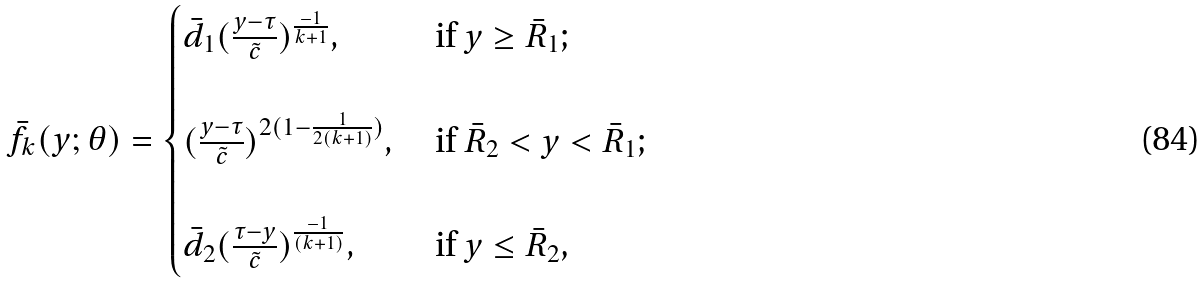Convert formula to latex. <formula><loc_0><loc_0><loc_500><loc_500>\bar { f } _ { k } ( y ; \theta ) = \begin{cases} \bar { d } _ { 1 } ( \frac { y - \tau } { \tilde { c } } ) ^ { \frac { - 1 } { k + 1 } } , & \text    { if $y\geq \bar{R}_{1}$;} \\ \\ ( \frac { y - \tau } { \tilde { c } } ) ^ { 2 ( 1 - \frac { 1 } { 2 ( k + 1 ) } ) } , & \text    { if $\bar{R}_{2} < y < \bar{R}_{1}$;} \\ \\ \bar { d } _ { 2 } ( \frac { \tau - y } { \tilde { c } } ) ^ { \frac { - 1 } { ( k + 1 ) } } , & \text    { if $y\leq \bar{R}_{2}$,} \\ \end{cases}</formula> 